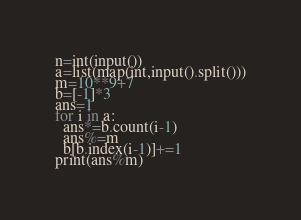Convert code to text. <code><loc_0><loc_0><loc_500><loc_500><_Python_>n=int(input())
a=list(map(int,input().split()))
m=10**9+7
b=[-1]*3
ans=1
for i in a:
  ans*=b.count(i-1)
  ans%=m
  b[b.index(i-1)]+=1
print(ans%m)</code> 